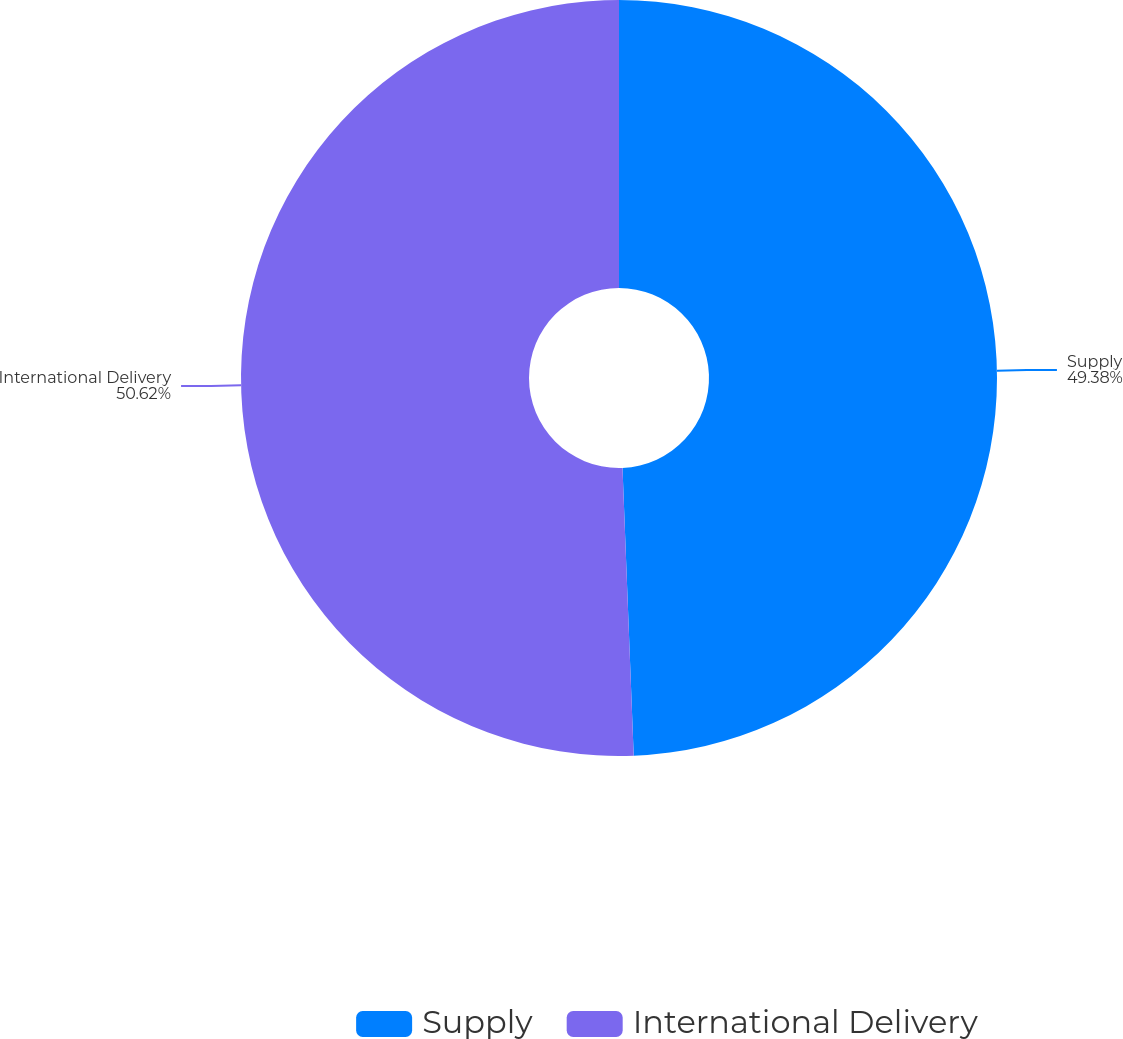Convert chart. <chart><loc_0><loc_0><loc_500><loc_500><pie_chart><fcel>Supply<fcel>International Delivery<nl><fcel>49.38%<fcel>50.62%<nl></chart> 